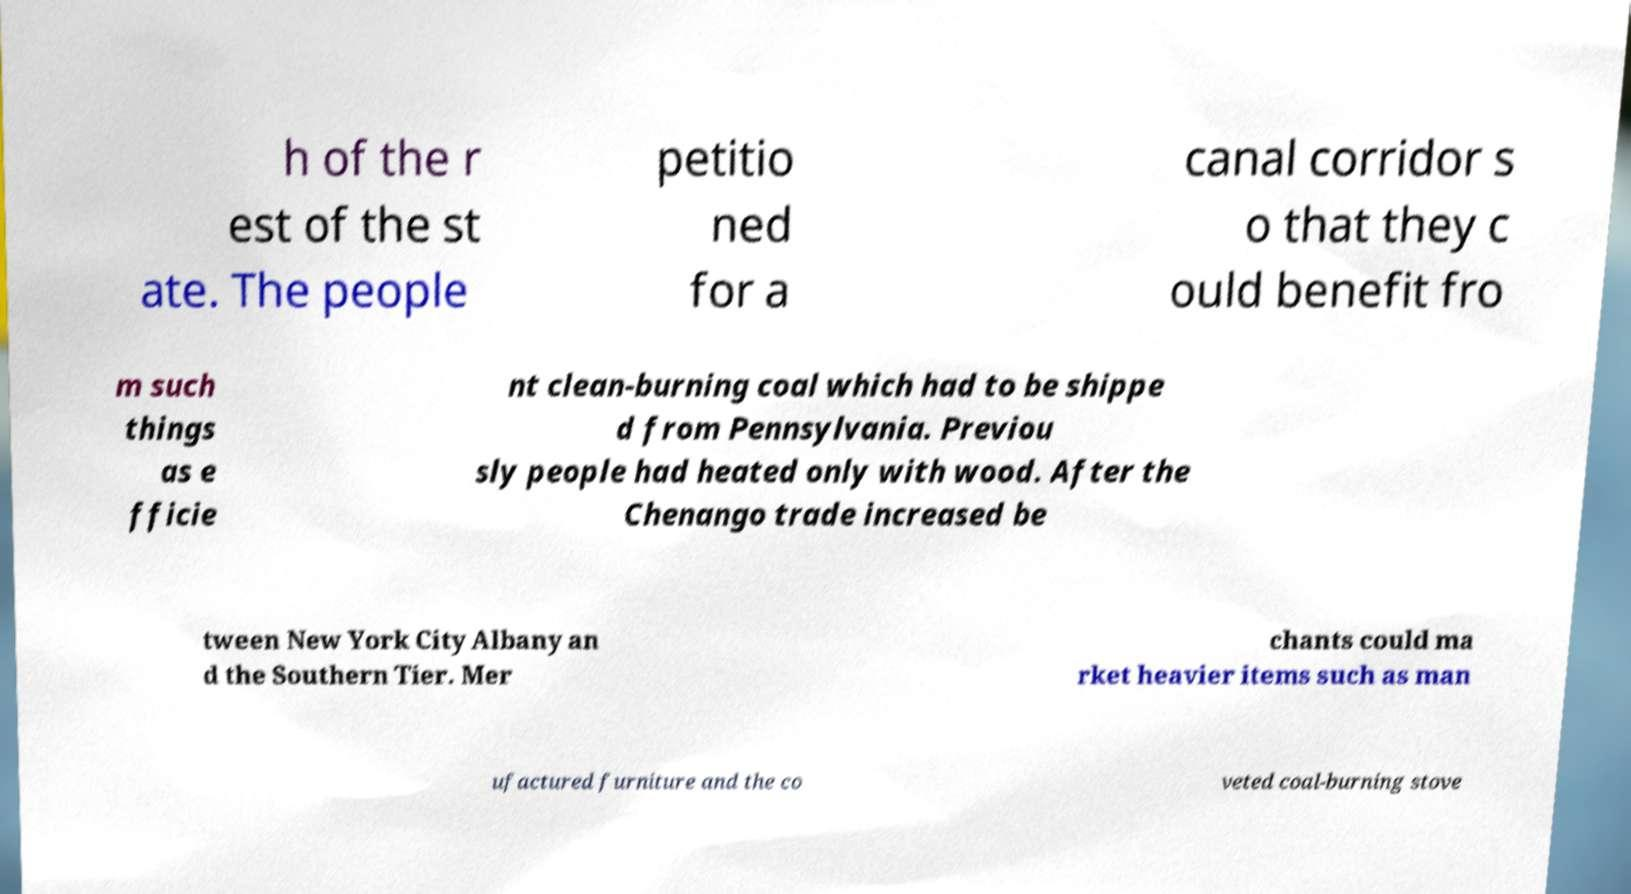Please identify and transcribe the text found in this image. h of the r est of the st ate. The people petitio ned for a canal corridor s o that they c ould benefit fro m such things as e fficie nt clean-burning coal which had to be shippe d from Pennsylvania. Previou sly people had heated only with wood. After the Chenango trade increased be tween New York City Albany an d the Southern Tier. Mer chants could ma rket heavier items such as man ufactured furniture and the co veted coal-burning stove 